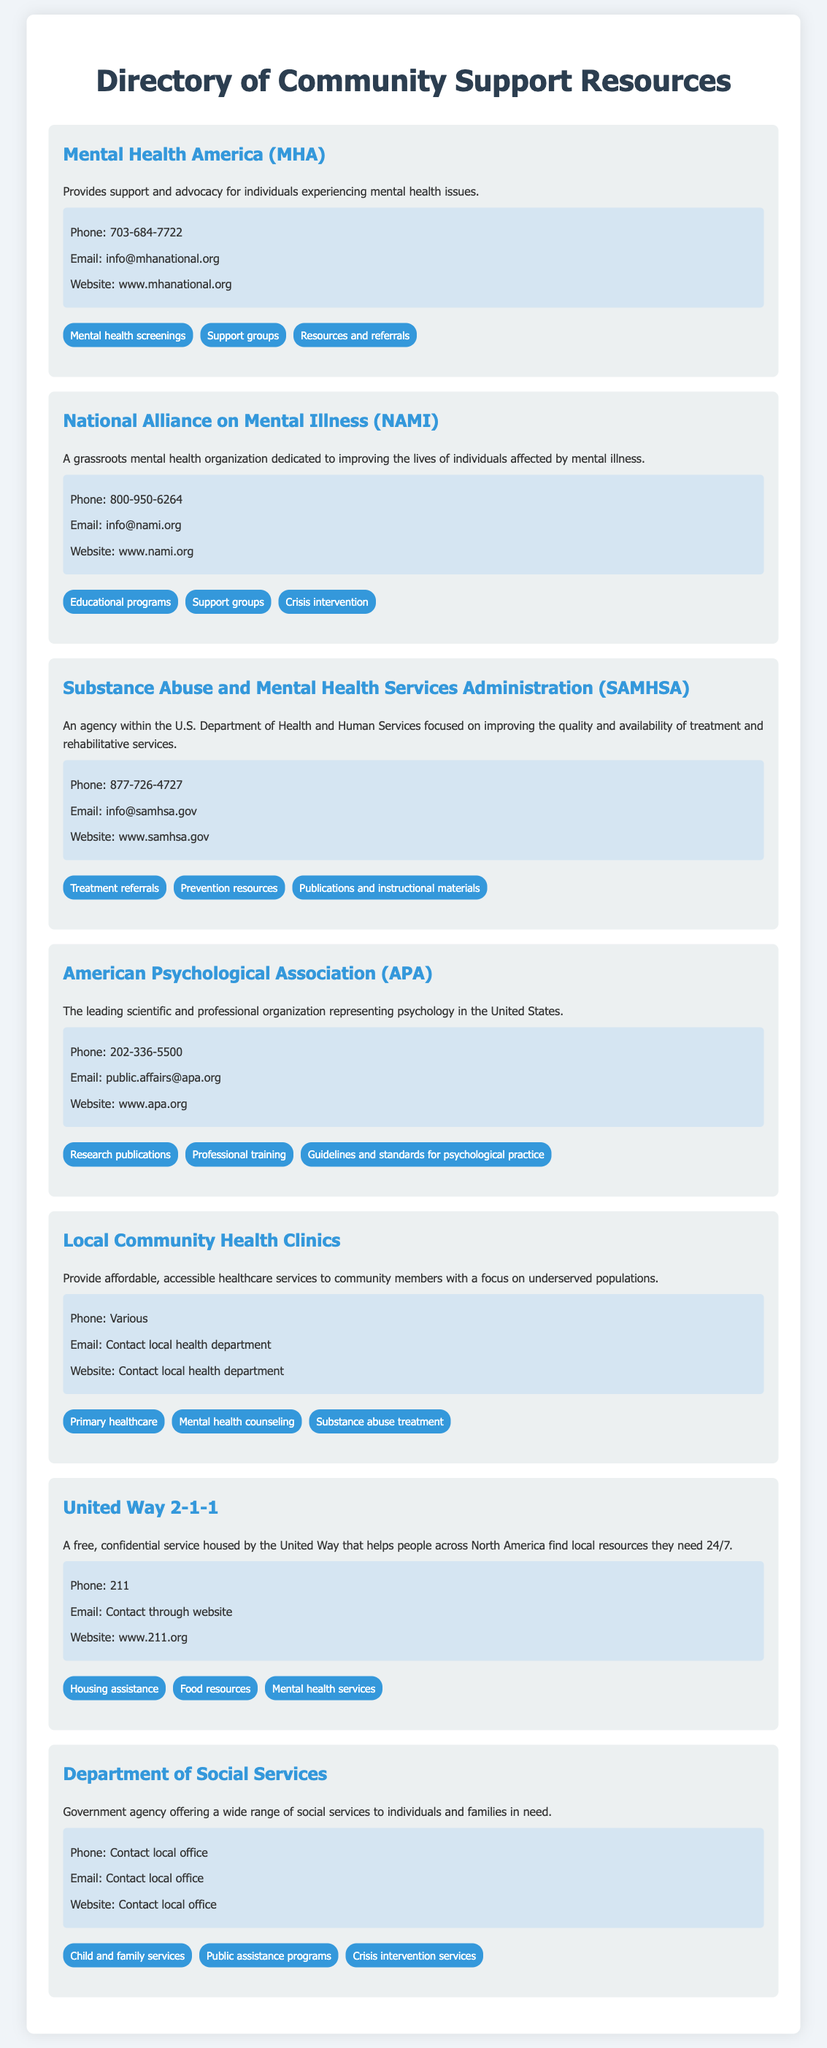What is the phone number for Mental Health America? The phone number for Mental Health America is listed in the contact information section of the document.
Answer: 703-684-7722 What services does NAMI provide? The services offered by NAMI are mentioned in the list of services they provide in the document.
Answer: Educational programs, Support groups, Crisis intervention What is the website for SAMHSA? The website for SAMHSA can be found in the contact information section of their service description.
Answer: www.samhsa.gov Which organization provides primary healthcare services? Primary healthcare services are listed under the Local Community Health Clinics section.
Answer: Local Community Health Clinics What is the main focus of the Department of Social Services? The main focus is described in the overview of the Department of Social Services in the document.
Answer: A wide range of social services What is the email address for the American Psychological Association? This information is contained within the contact information of the APA section in the document.
Answer: public.affairs@apa.org How can someone contact United Way 2-1-1? Contact information for United Way 2-1-1 is listed in the document, specifying their phone number.
Answer: 211 What type of service does Mental Health America offer regarding mental health? This information can be found in the services offered by MHA in the document.
Answer: Mental health screenings 